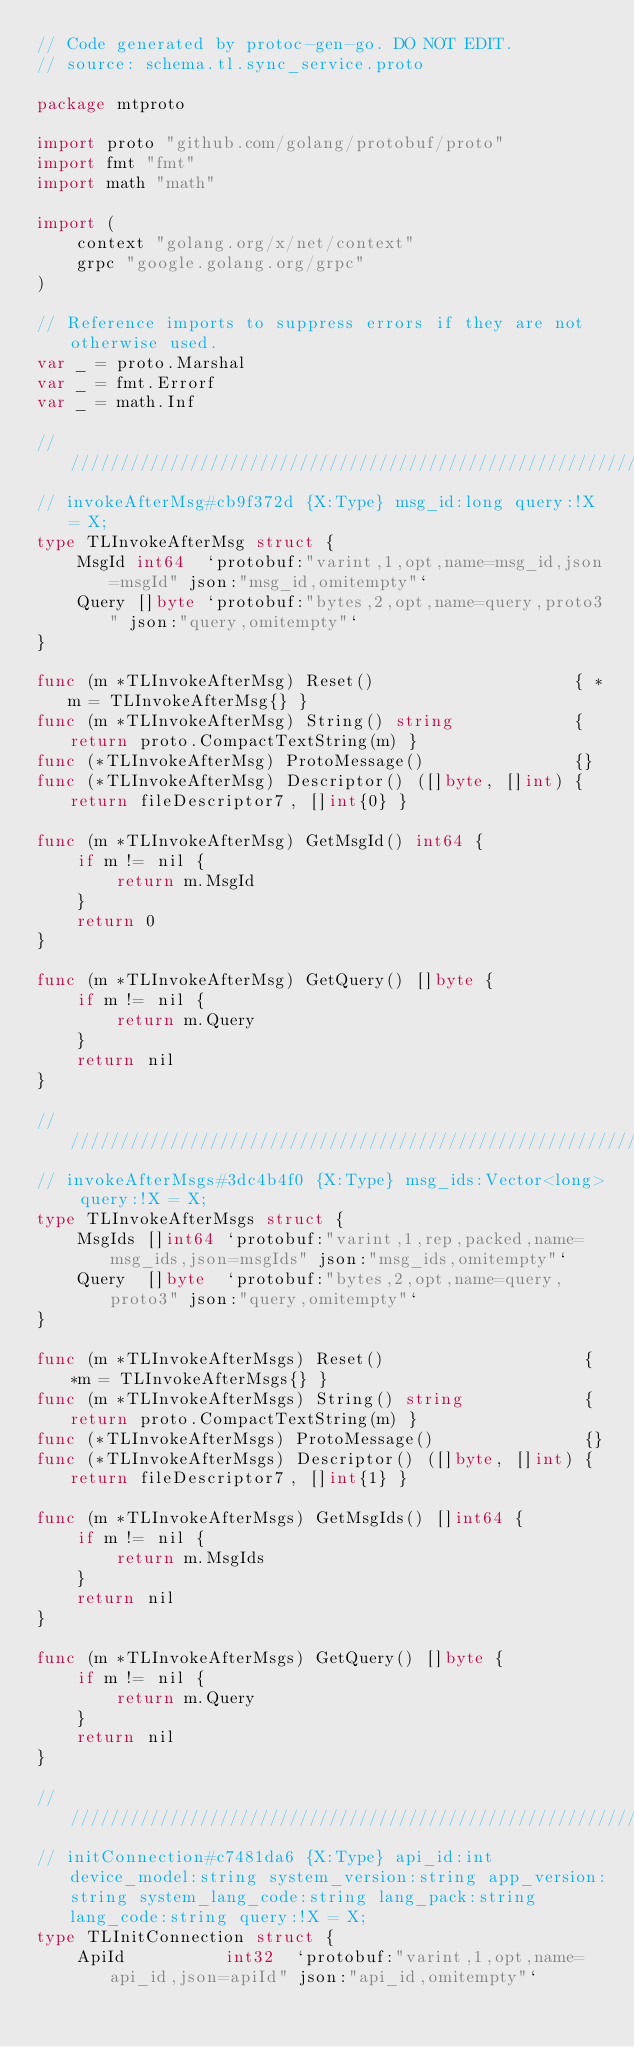Convert code to text. <code><loc_0><loc_0><loc_500><loc_500><_Go_>// Code generated by protoc-gen-go. DO NOT EDIT.
// source: schema.tl.sync_service.proto

package mtproto

import proto "github.com/golang/protobuf/proto"
import fmt "fmt"
import math "math"

import (
	context "golang.org/x/net/context"
	grpc "google.golang.org/grpc"
)

// Reference imports to suppress errors if they are not otherwise used.
var _ = proto.Marshal
var _ = fmt.Errorf
var _ = math.Inf

// /////////////////////////////////////////////////////////////////////////////
// invokeAfterMsg#cb9f372d {X:Type} msg_id:long query:!X = X;
type TLInvokeAfterMsg struct {
	MsgId int64  `protobuf:"varint,1,opt,name=msg_id,json=msgId" json:"msg_id,omitempty"`
	Query []byte `protobuf:"bytes,2,opt,name=query,proto3" json:"query,omitempty"`
}

func (m *TLInvokeAfterMsg) Reset()                    { *m = TLInvokeAfterMsg{} }
func (m *TLInvokeAfterMsg) String() string            { return proto.CompactTextString(m) }
func (*TLInvokeAfterMsg) ProtoMessage()               {}
func (*TLInvokeAfterMsg) Descriptor() ([]byte, []int) { return fileDescriptor7, []int{0} }

func (m *TLInvokeAfterMsg) GetMsgId() int64 {
	if m != nil {
		return m.MsgId
	}
	return 0
}

func (m *TLInvokeAfterMsg) GetQuery() []byte {
	if m != nil {
		return m.Query
	}
	return nil
}

// /////////////////////////////////////////////////////////////////////////////
// invokeAfterMsgs#3dc4b4f0 {X:Type} msg_ids:Vector<long> query:!X = X;
type TLInvokeAfterMsgs struct {
	MsgIds []int64 `protobuf:"varint,1,rep,packed,name=msg_ids,json=msgIds" json:"msg_ids,omitempty"`
	Query  []byte  `protobuf:"bytes,2,opt,name=query,proto3" json:"query,omitempty"`
}

func (m *TLInvokeAfterMsgs) Reset()                    { *m = TLInvokeAfterMsgs{} }
func (m *TLInvokeAfterMsgs) String() string            { return proto.CompactTextString(m) }
func (*TLInvokeAfterMsgs) ProtoMessage()               {}
func (*TLInvokeAfterMsgs) Descriptor() ([]byte, []int) { return fileDescriptor7, []int{1} }

func (m *TLInvokeAfterMsgs) GetMsgIds() []int64 {
	if m != nil {
		return m.MsgIds
	}
	return nil
}

func (m *TLInvokeAfterMsgs) GetQuery() []byte {
	if m != nil {
		return m.Query
	}
	return nil
}

// /////////////////////////////////////////////////////////////////////////////
// initConnection#c7481da6 {X:Type} api_id:int device_model:string system_version:string app_version:string system_lang_code:string lang_pack:string lang_code:string query:!X = X;
type TLInitConnection struct {
	ApiId          int32  `protobuf:"varint,1,opt,name=api_id,json=apiId" json:"api_id,omitempty"`</code> 